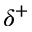Convert formula to latex. <formula><loc_0><loc_0><loc_500><loc_500>\delta ^ { + }</formula> 